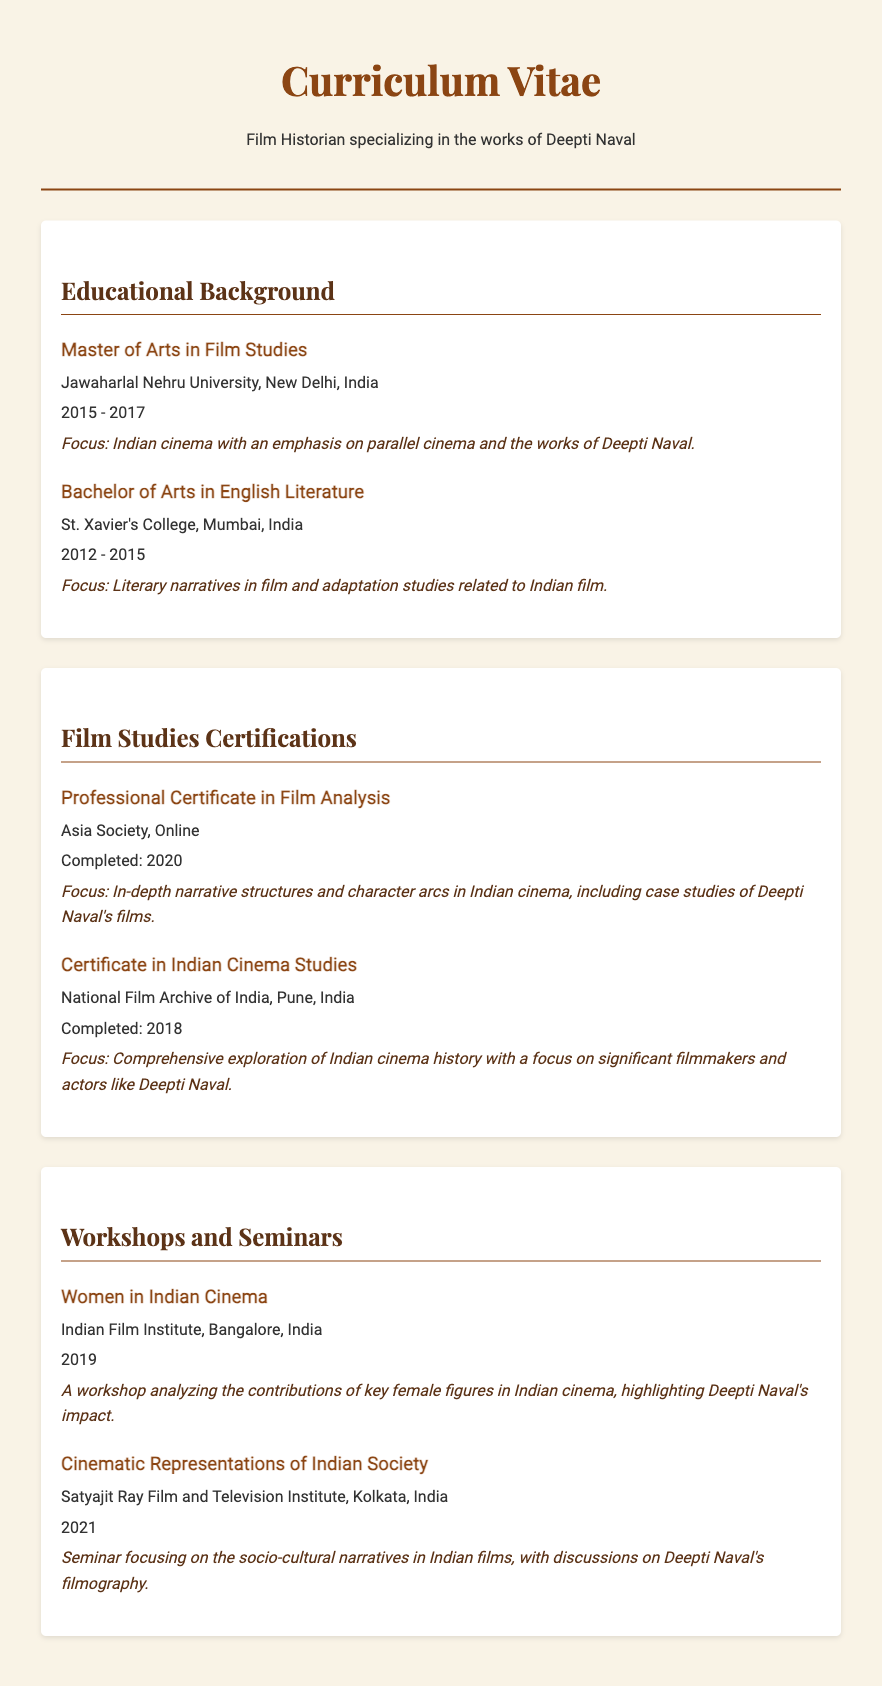what is the highest degree earned? The highest degree mentioned in the document is the Master of Arts in Film Studies.
Answer: Master of Arts in Film Studies which university awarded the Bachelor's degree? The Bachelor's degree was awarded by St. Xavier's College.
Answer: St. Xavier's College in what year was the Professional Certificate in Film Analysis completed? The Professional Certificate in Film Analysis was completed in 2020.
Answer: 2020 what is the focus of the Master's degree? The focus of the Master's degree is Indian cinema with an emphasis on parallel cinema and the works of Deepti Naval.
Answer: Indian cinema with an emphasis on parallel cinema and the works of Deepti Naval who is a key figure highlighted in the workshop about Women in Indian Cinema? The workshop highlights the contributions of Deepti Naval.
Answer: Deepti Naval what institution provided the Certificate in Indian Cinema Studies? The Certificate in Indian Cinema Studies was provided by the National Film Archive of India.
Answer: National Film Archive of India how many years did the Bachelor's degree span? The Bachelor's degree spanned from 2012 to 2015, thus it was for three years.
Answer: three years which city is associated with the Indian Film Institute? The Indian Film Institute is located in Bangalore.
Answer: Bangalore what is a specific focus of the seminar on Cinematic Representations of Indian Society? The seminar focuses on socio-cultural narratives in Indian films.
Answer: socio-cultural narratives in Indian films 